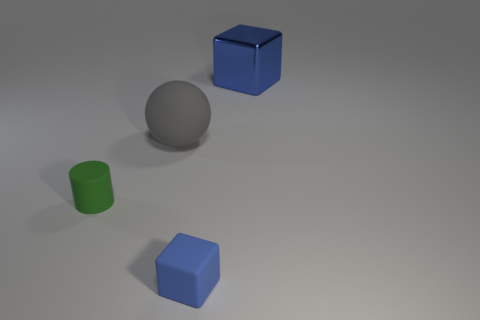The ball has what color? gray 